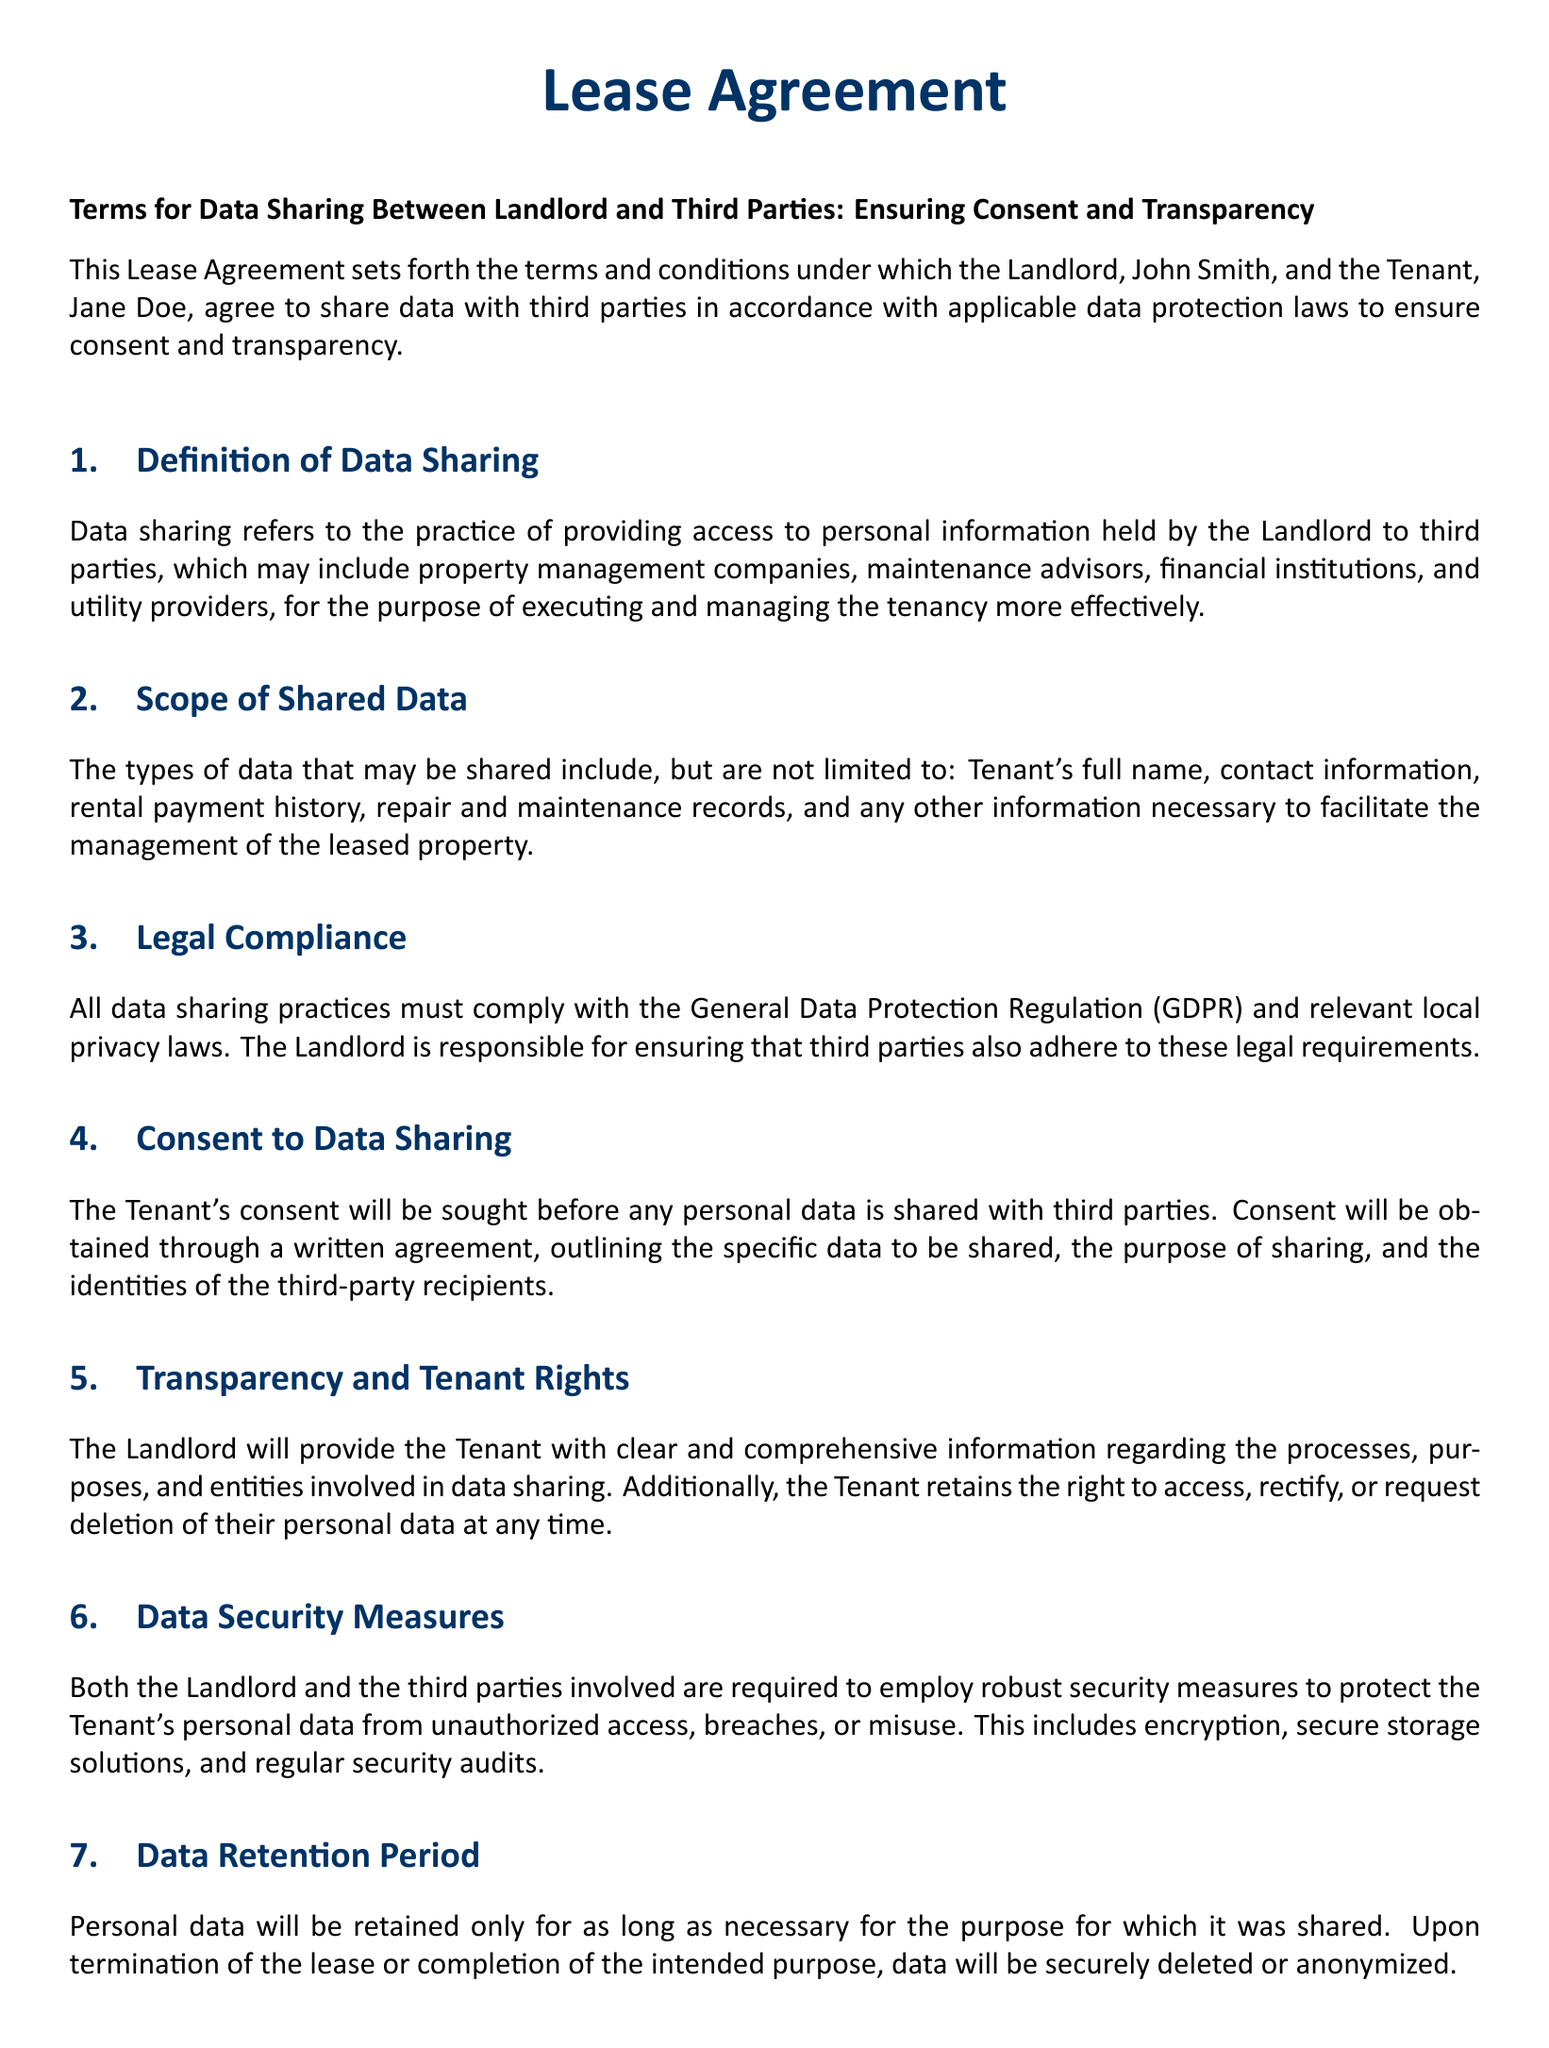What is the landlord's name? The landlord's name is stated at the beginning of the document as John Smith.
Answer: John Smith What is the tenant's name? The tenant's name is provided in the introduction of the document as Jane Doe.
Answer: Jane Doe What type of data may be shared? The document lists several types of data that may be shared, including the tenant's full name and rental payment history.
Answer: Tenant's full name, contact information, rental payment history, repair and maintenance records What regulation must be complied with? The document specifies that all data sharing practices must comply with the General Data Protection Regulation.
Answer: General Data Protection Regulation (GDPR) What must be obtained before sharing personal data? The tenant's permission is required before sharing personal data with third parties, as indicated in the section on consent.
Answer: Consent What is the tenant's right regarding their data? The document states that the tenant retains the right to access, rectify, or request deletion of their personal data.
Answer: Access, rectify, or request deletion What security measures are required? The landlord and third parties must employ robust security measures to protect tenant data, including encryption and secure storage.
Answer: Encryption, secure storage How long will personal data be retained? The document indicates that personal data will be retained only for as long as necessary for its intended purpose.
Answer: Only as long as necessary What is the contact email for the landlord? The landlord's contact email is provided in the document for any questions regarding data sharing practices.
Answer: info@johnsmithproperties.com 